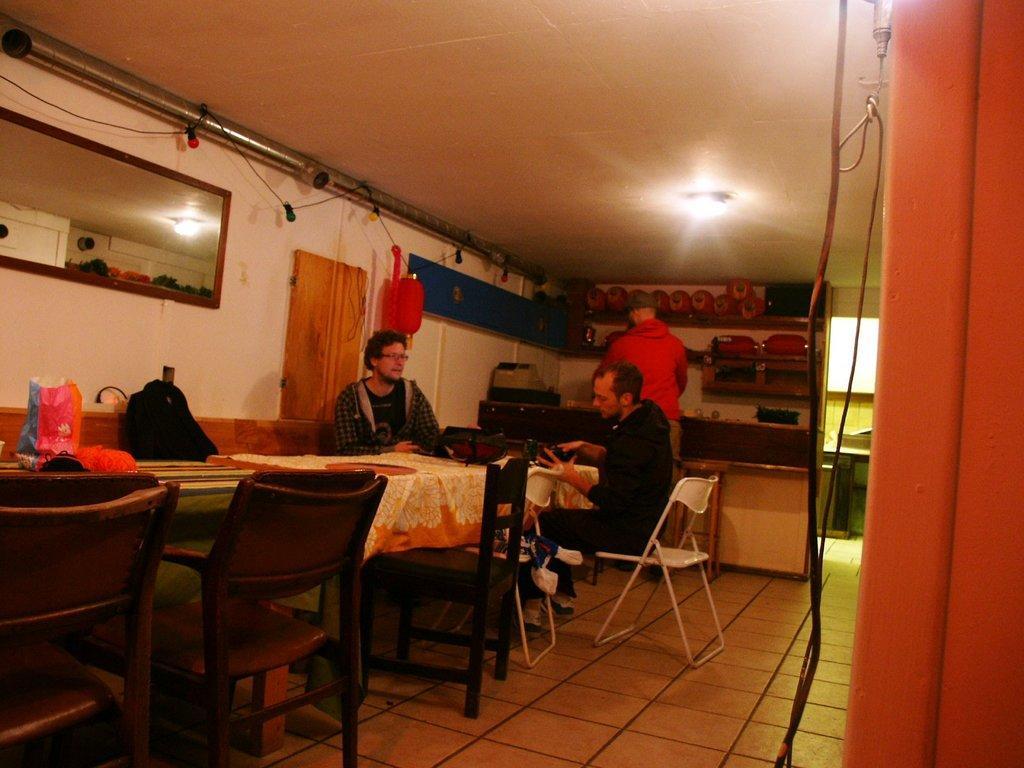Describe this image in one or two sentences. This is the picture of the inside of the room. There are 3 people. On the right side we have a red color shirt person. His standing and remaining persons are sitting in a chair. There is a table and chair. There is a cover and bags on a table. We can in the background wall,curtain and mirror is their. 